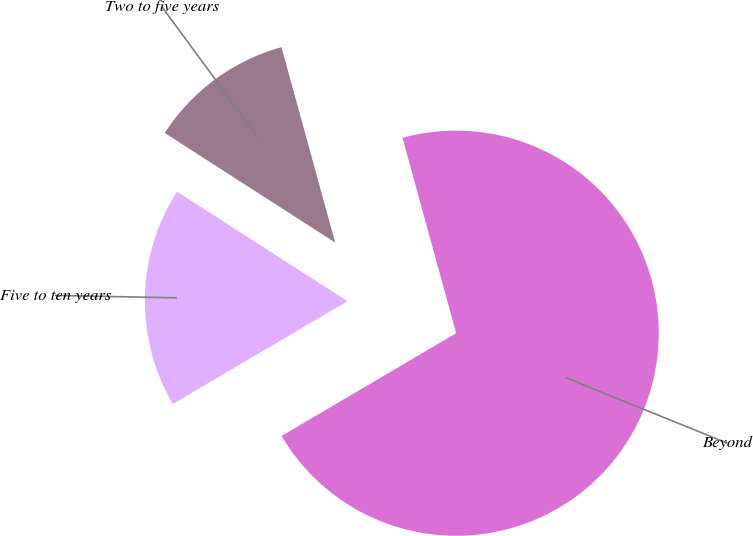Convert chart to OTSL. <chart><loc_0><loc_0><loc_500><loc_500><pie_chart><fcel>Two to five years<fcel>Five to ten years<fcel>Beyond<nl><fcel>11.64%<fcel>17.56%<fcel>70.8%<nl></chart> 